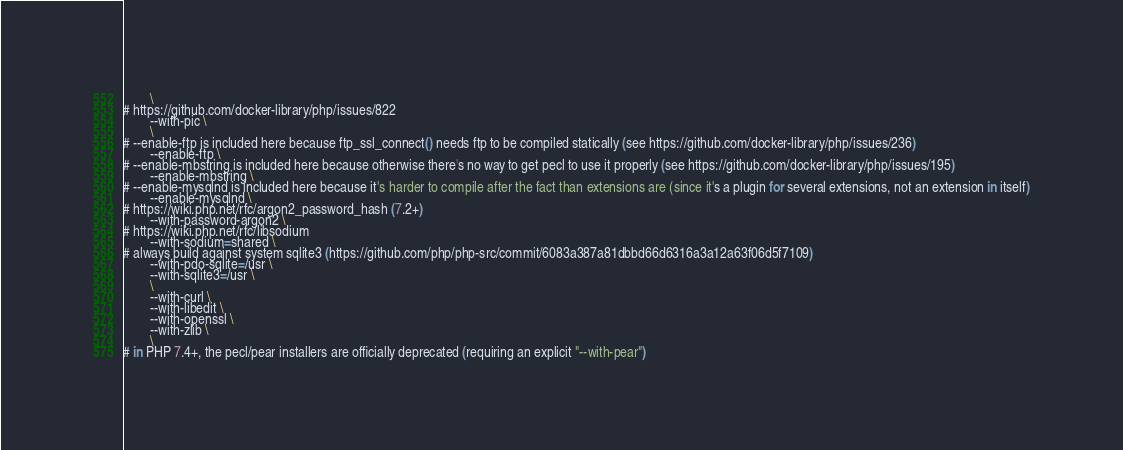<code> <loc_0><loc_0><loc_500><loc_500><_Dockerfile_>		\
# https://github.com/docker-library/php/issues/822
		--with-pic \
		\
# --enable-ftp is included here because ftp_ssl_connect() needs ftp to be compiled statically (see https://github.com/docker-library/php/issues/236)
		--enable-ftp \
# --enable-mbstring is included here because otherwise there's no way to get pecl to use it properly (see https://github.com/docker-library/php/issues/195)
		--enable-mbstring \
# --enable-mysqlnd is included here because it's harder to compile after the fact than extensions are (since it's a plugin for several extensions, not an extension in itself)
		--enable-mysqlnd \
# https://wiki.php.net/rfc/argon2_password_hash (7.2+)
		--with-password-argon2 \
# https://wiki.php.net/rfc/libsodium
		--with-sodium=shared \
# always build against system sqlite3 (https://github.com/php/php-src/commit/6083a387a81dbbd66d6316a3a12a63f06d5f7109)
		--with-pdo-sqlite=/usr \
		--with-sqlite3=/usr \
		\
		--with-curl \
		--with-libedit \
		--with-openssl \
		--with-zlib \
		\
# in PHP 7.4+, the pecl/pear installers are officially deprecated (requiring an explicit "--with-pear")</code> 